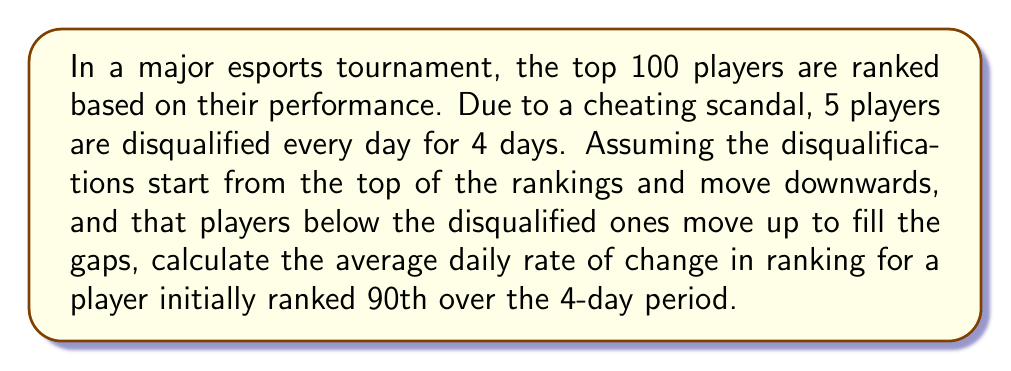Help me with this question. Let's approach this step-by-step:

1) First, we need to determine how many positions the 90th ranked player will move up each day:

   Day 1: Moves up 5 positions
   Day 2: Moves up 5 positions
   Day 3: Moves up 5 positions
   Day 4: Moves up 5 positions

2) Over the 4-day period, the player will move up a total of:

   $$ 5 + 5 + 5 + 5 = 20 \text{ positions} $$

3) The player's final ranking after 4 days will be:

   $$ 90 - 20 = 70 $$

4) To calculate the average daily rate of change, we use the formula:

   $$ \text{Average Rate of Change} = \frac{\text{Change in Ranking}}{\text{Number of Days}} $$

5) Substituting our values:

   $$ \text{Average Rate of Change} = \frac{90 - 70}{4} = \frac{20}{4} = 5 $$

Therefore, the average daily rate of change in ranking for the player initially ranked 90th is 5 positions per day.
Answer: 5 positions per day 